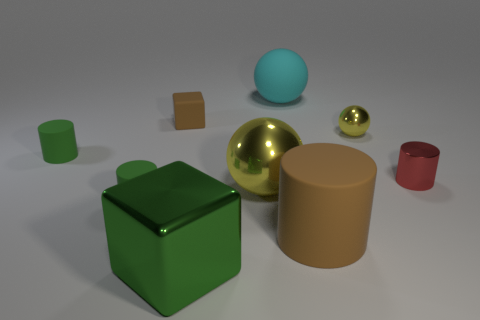What number of other objects are the same color as the large cylinder?
Provide a succinct answer. 1. What is the shape of the brown object right of the large metal block?
Provide a succinct answer. Cylinder. How many things are small green matte cylinders or large cyan spheres?
Ensure brevity in your answer.  3. There is a shiny cube; is it the same size as the brown matte object that is left of the green cube?
Your answer should be compact. No. What number of other things are the same material as the small brown cube?
Keep it short and to the point. 4. How many objects are either blocks to the left of the green metallic thing or small cylinders right of the brown cylinder?
Give a very brief answer. 2. There is a brown thing that is the same shape as the large green object; what material is it?
Make the answer very short. Rubber. Are there any cyan rubber cubes?
Provide a short and direct response. No. What is the size of the cylinder that is on the right side of the tiny block and on the left side of the red metallic object?
Provide a succinct answer. Large. There is a large cyan matte object; what shape is it?
Provide a short and direct response. Sphere. 